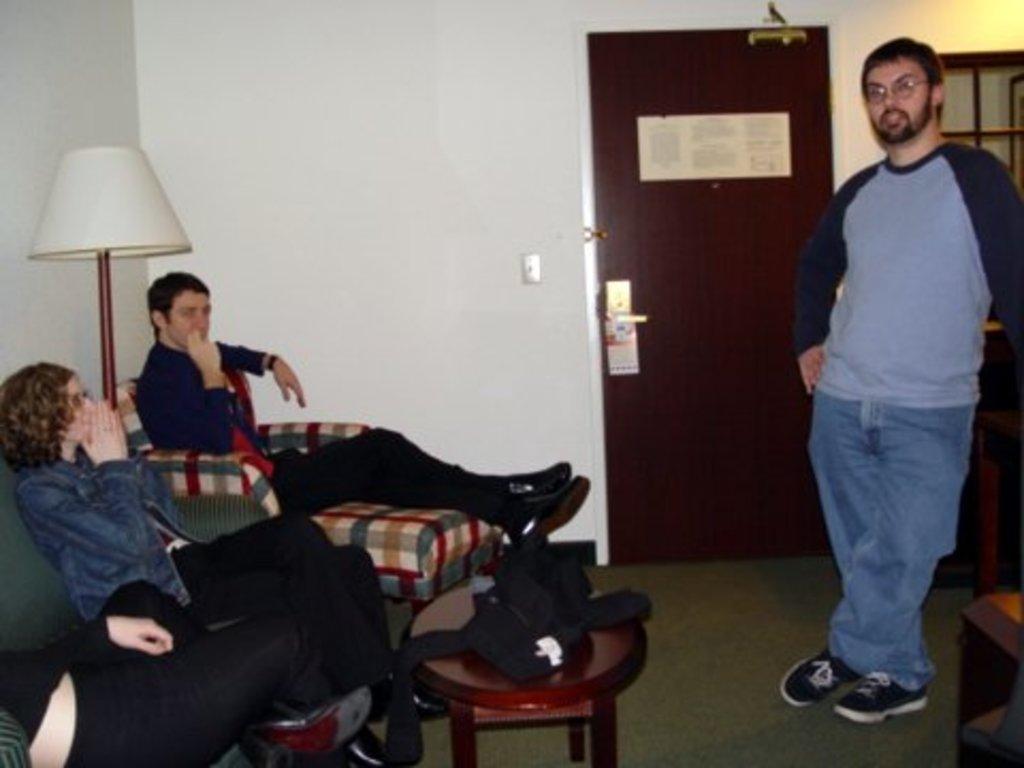Please provide a concise description of this image. In this picture, there are three people sitting on the sofas towards the left. In between them, there is a lamp. In the center, there is a table and a jacket is placed on it. Towards the right, there is a person wearing a grey top and blue jeans. In the background, there is a wall with door and window. 